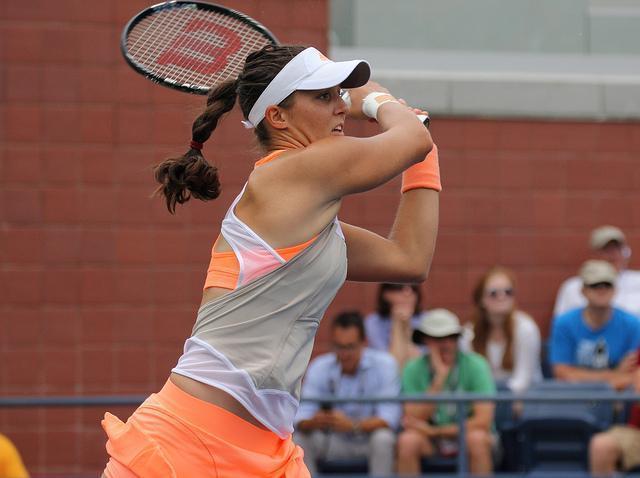How many people can be seen?
Give a very brief answer. 8. How many boats are there?
Give a very brief answer. 0. 